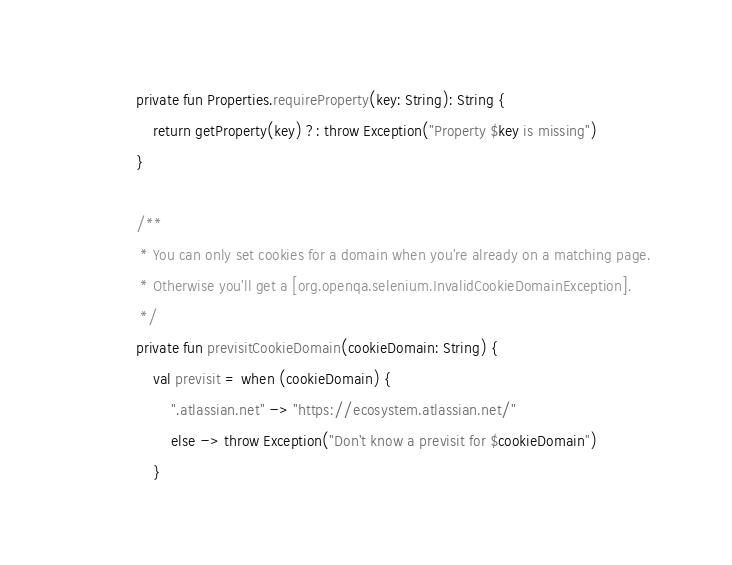<code> <loc_0><loc_0><loc_500><loc_500><_Kotlin_>    private fun Properties.requireProperty(key: String): String {
        return getProperty(key) ?: throw Exception("Property $key is missing")
    }

    /**
     * You can only set cookies for a domain when you're already on a matching page.
     * Otherwise you'll get a [org.openqa.selenium.InvalidCookieDomainException].
     */
    private fun previsitCookieDomain(cookieDomain: String) {
        val previsit = when (cookieDomain) {
            ".atlassian.net" -> "https://ecosystem.atlassian.net/"
            else -> throw Exception("Don't know a previsit for $cookieDomain")
        }</code> 